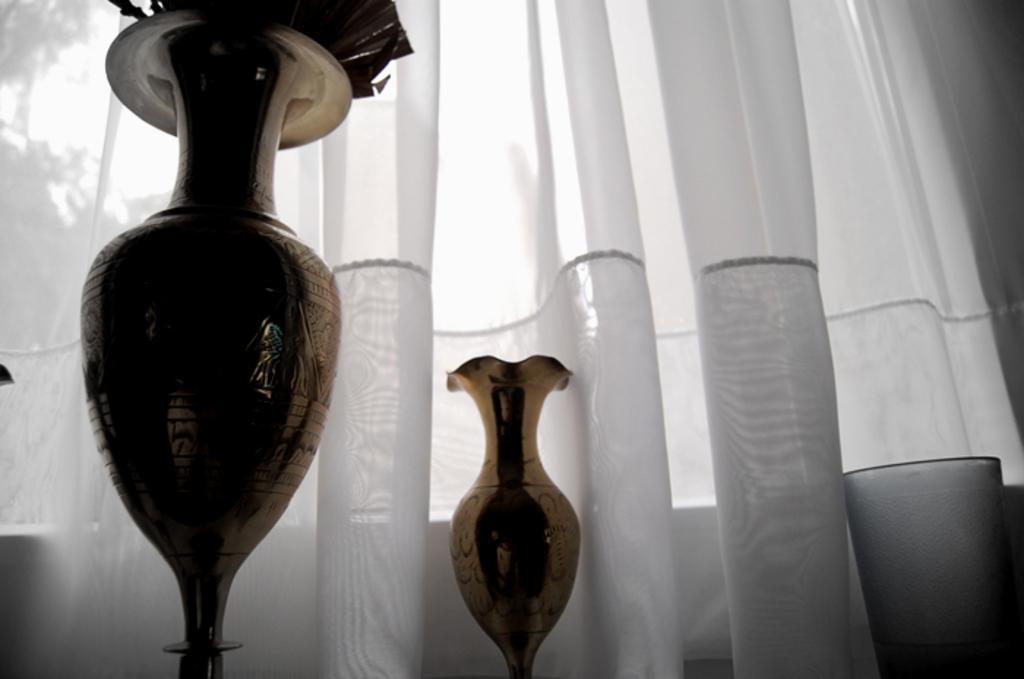Please provide a concise description of this image. In this picture I can see flower pots and white color curtain. 